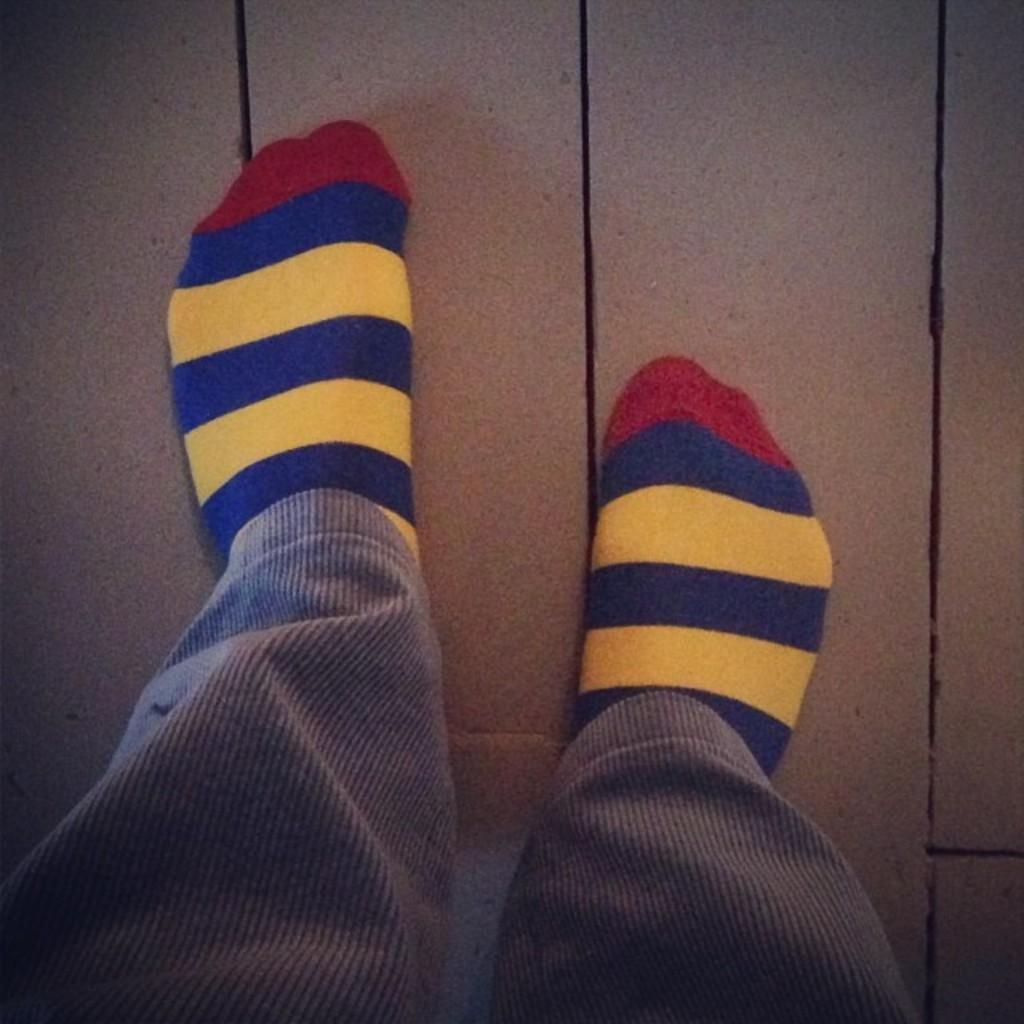What body parts are visible in the image? There are two human legs in the image. What are the legs wearing? The legs are wearing colorful socks. What type of flowers can be seen growing on the houses in the image? There are no flowers or houses present in the image; it only features two human legs wearing colorful socks. 